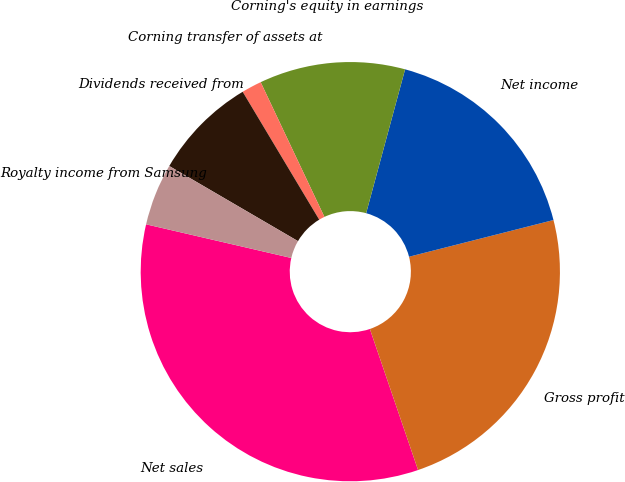Convert chart. <chart><loc_0><loc_0><loc_500><loc_500><pie_chart><fcel>Net sales<fcel>Gross profit<fcel>Net income<fcel>Corning's equity in earnings<fcel>Corning transfer of assets at<fcel>Dividends received from<fcel>Royalty income from Samsung<nl><fcel>33.86%<fcel>23.72%<fcel>16.83%<fcel>11.24%<fcel>1.55%<fcel>8.01%<fcel>4.78%<nl></chart> 